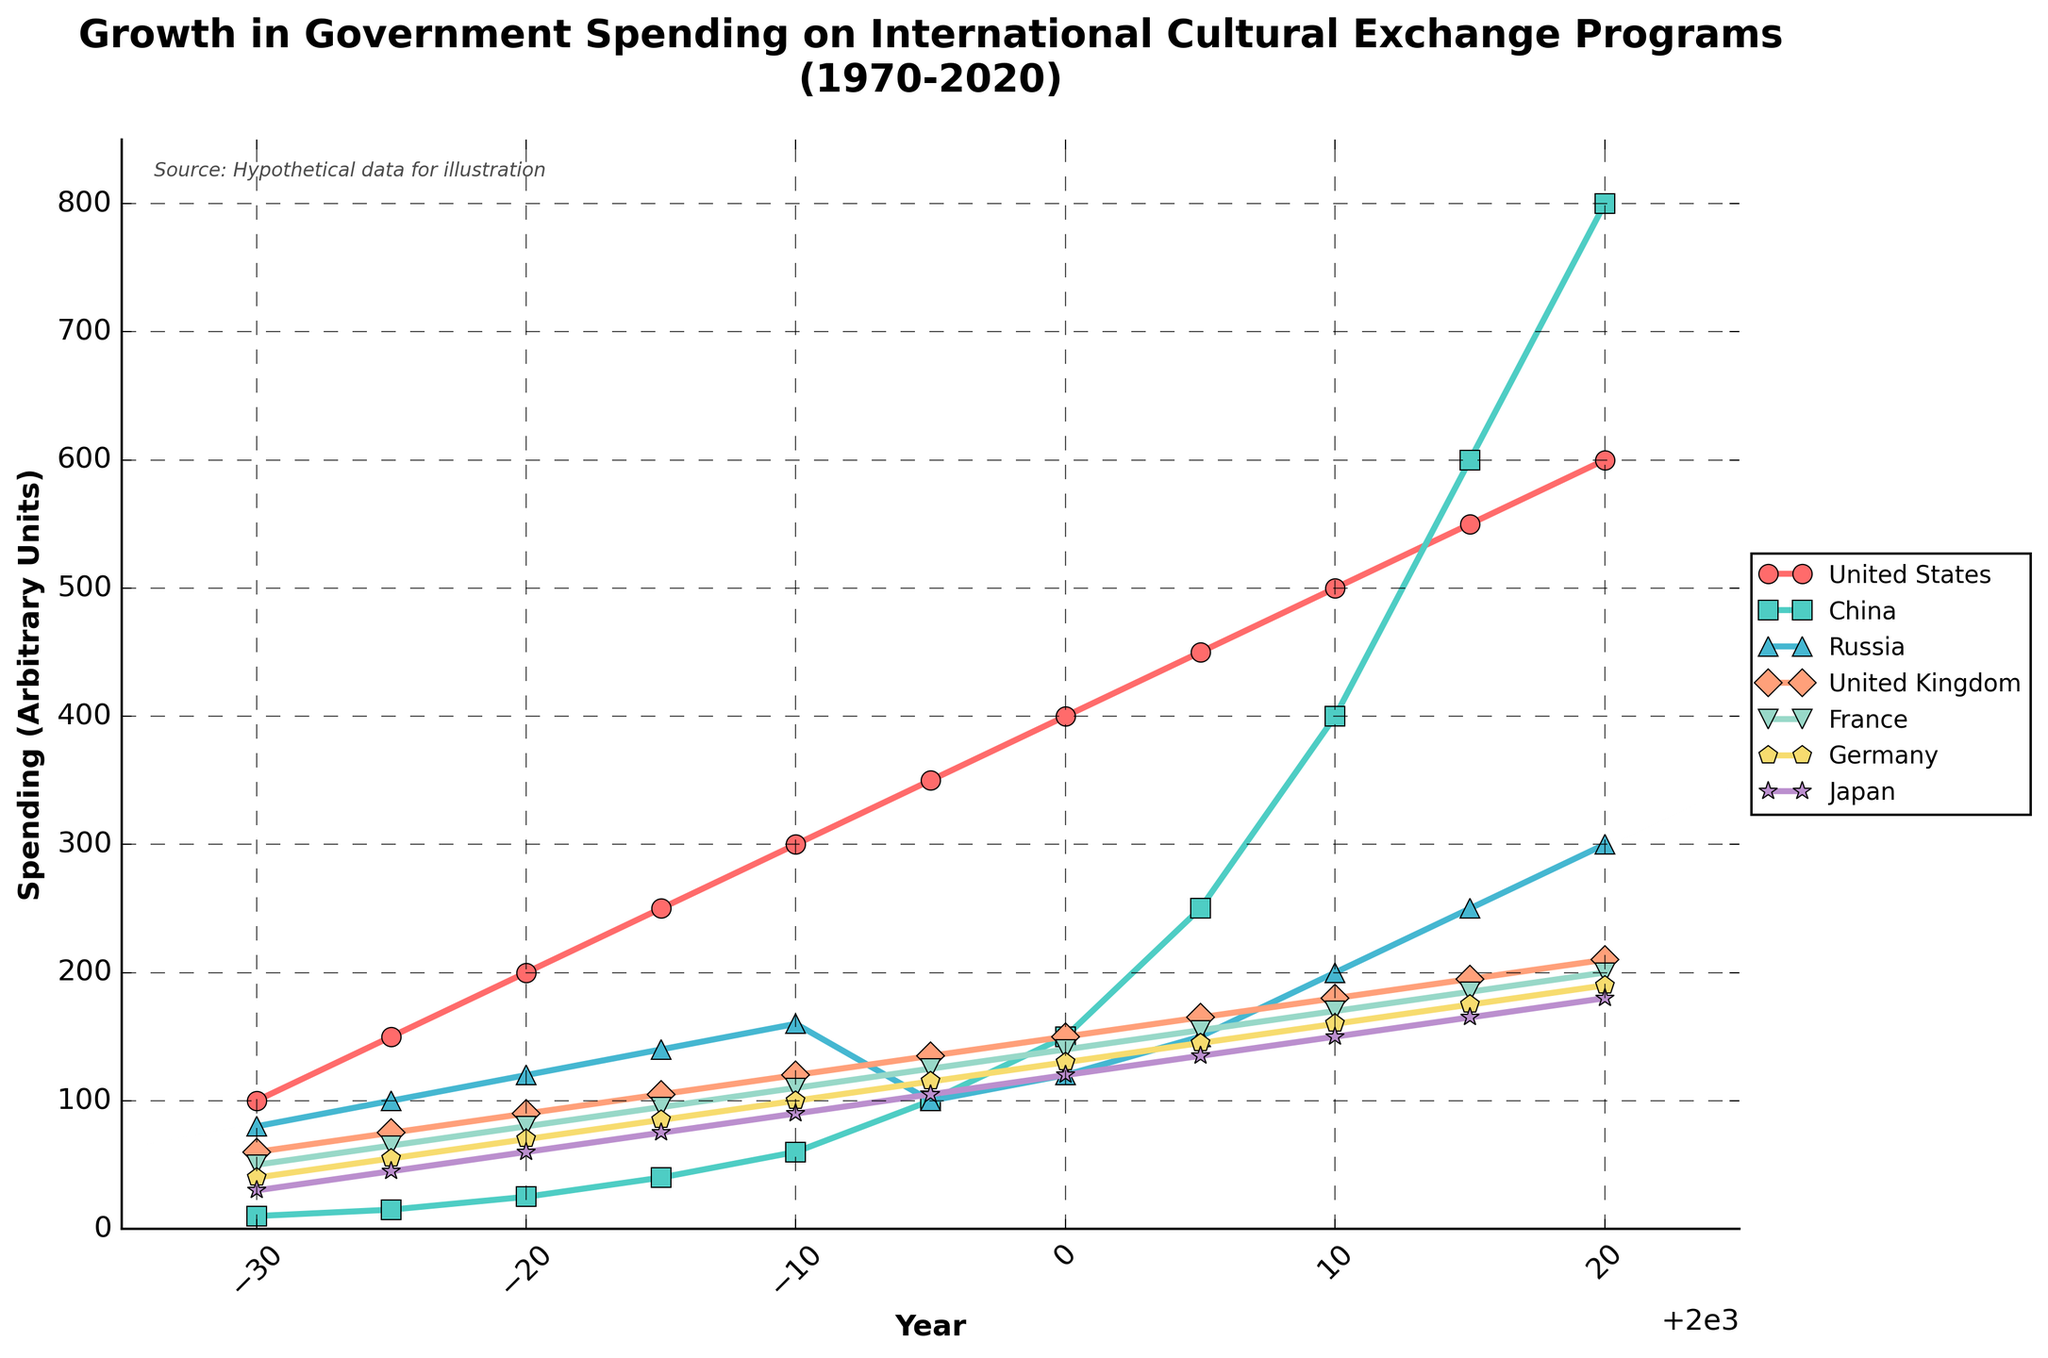what is the growth rate of China's spending from 1970 to 2020? Calculate the initial value in 1970, which is 10, and the final value in 2020, which is 800. The growth rate is (800 - 10) / 10 * 100%.
Answer: 7900% Which country had the least total spending growth over the years? Compute the differences in spending from 1970 to 2020 for each country: United States (600-100), China (800-10), Russia (300-80), United Kingdom (210-60), France (200-50), Germany (190-40), Japan (180-30). Then compare the differences.
Answer: Japan When did Russia’s spending first exceed 200? Examine the data points for Russia and identify the first year when the value exceeds 200. Russia's spending hits 200 exactly in 2010.
Answer: 2010 Which country showed a dramatic surge in spending around 2005-2010? Look at the lines on the plot and identify the country whose spending line displays a steep incline between 2005 and 2010. China's line shows a dramatic increase.
Answer: China Which country's spending in 2000 was closest to France's spending in the same year? Examine the data points for 2000 and determine which country's spending is closest to France's data point of 140 units. Germany's spending is 130, which is the closest.
Answer: Germany What is the average spending of Japan over the 50 years? Sum Japan's spending over all years and divide by the number of data points, which is 11. (30+45+60+75+90+105+120+135+150+165+180)/11 = 113.64.
Answer: 113.64 Which two countries had almost overlapping growth in their spending in the 1980s? Examine the plot closely and identify which countries’ lines almost overlap during the 1980-1990 period. The United Kingdom and France's lines overlap during this period.
Answer: United Kingdom and France How does the peak spending of Russia compare to the peak spending of the United Kingdom? Identify the peak spending values for Russia (300 in 2020) and the United Kingdom (210 in 2020) and compare.
Answer: Russia has higher peak spending In which year did Germany's spending first reach 100 units? Look at Germany’s data points and find the year when it first hits 100 units, which occurs in 1990.
Answer: 1990 Which country shows a consistently linear growth pattern from 1970 to 2020? By visual inspection, determine which country's spending line follows a linear growth pattern throughout the entire period. The United States exhibits a consistent linear growth.
Answer: United States 